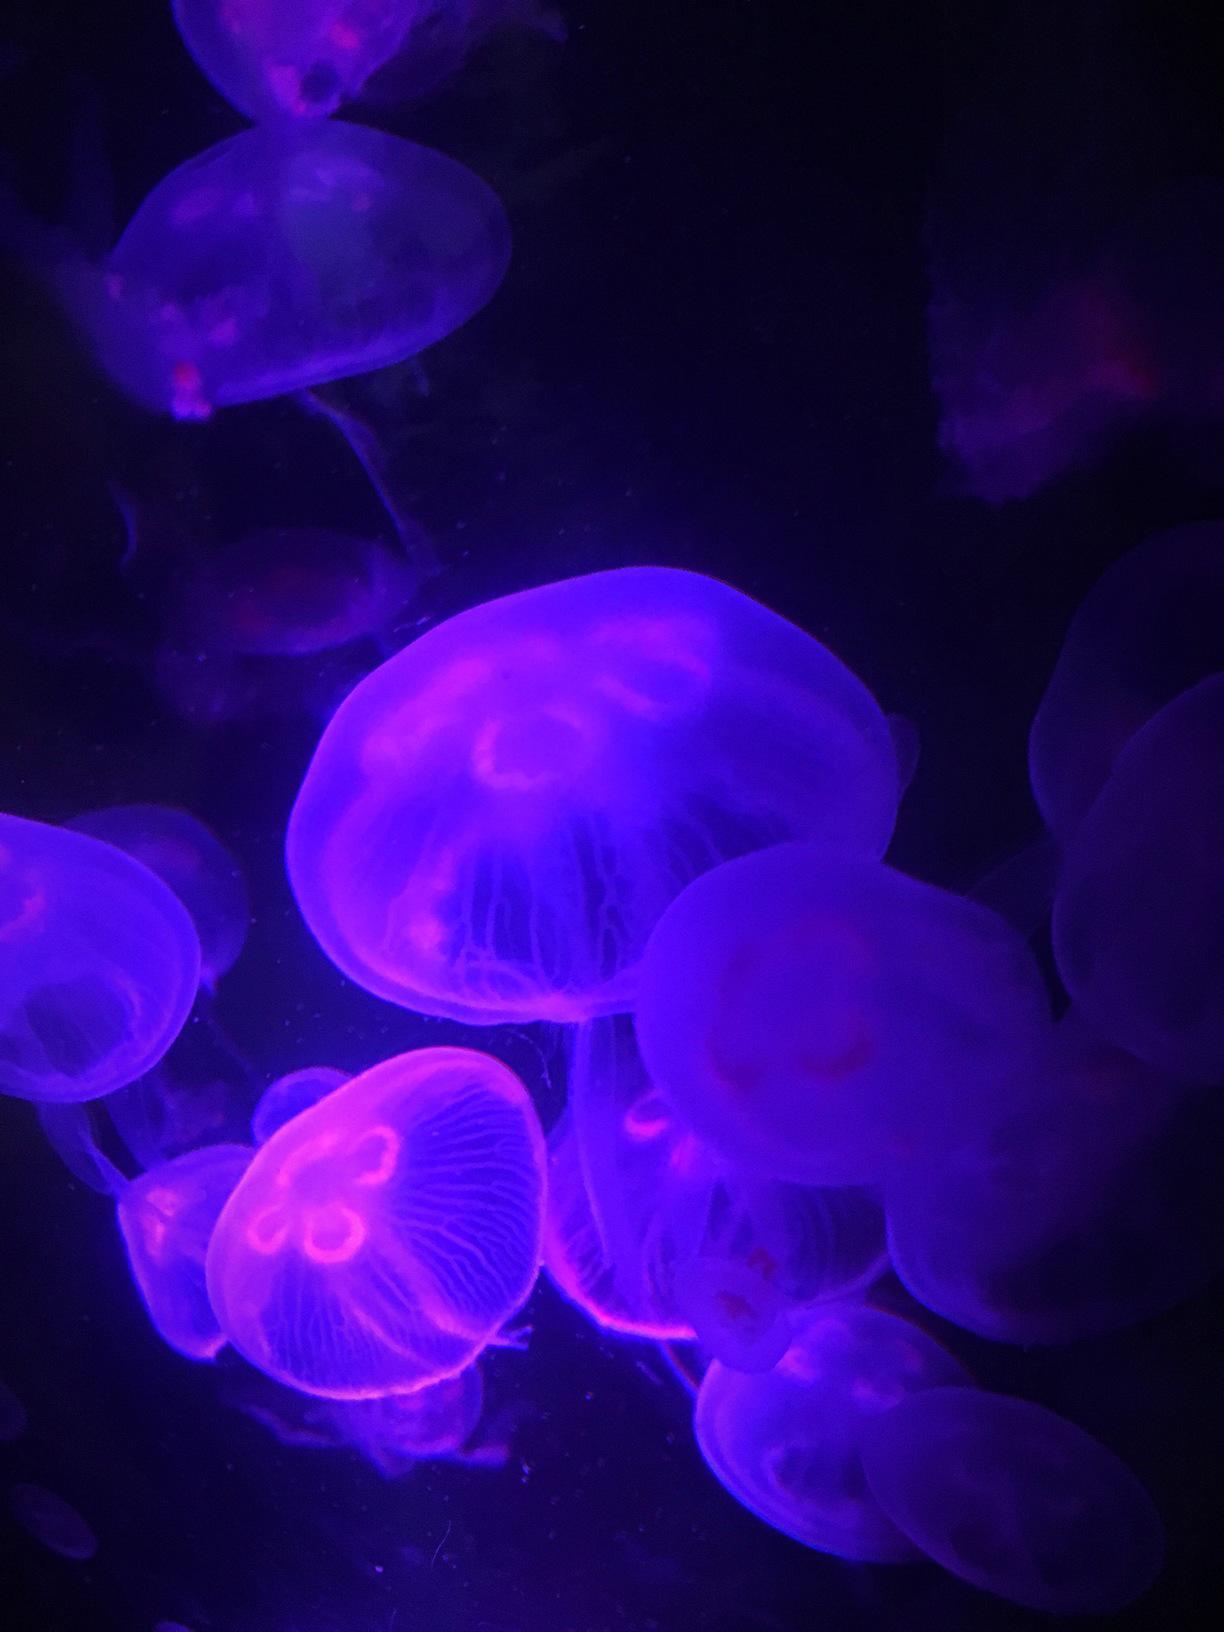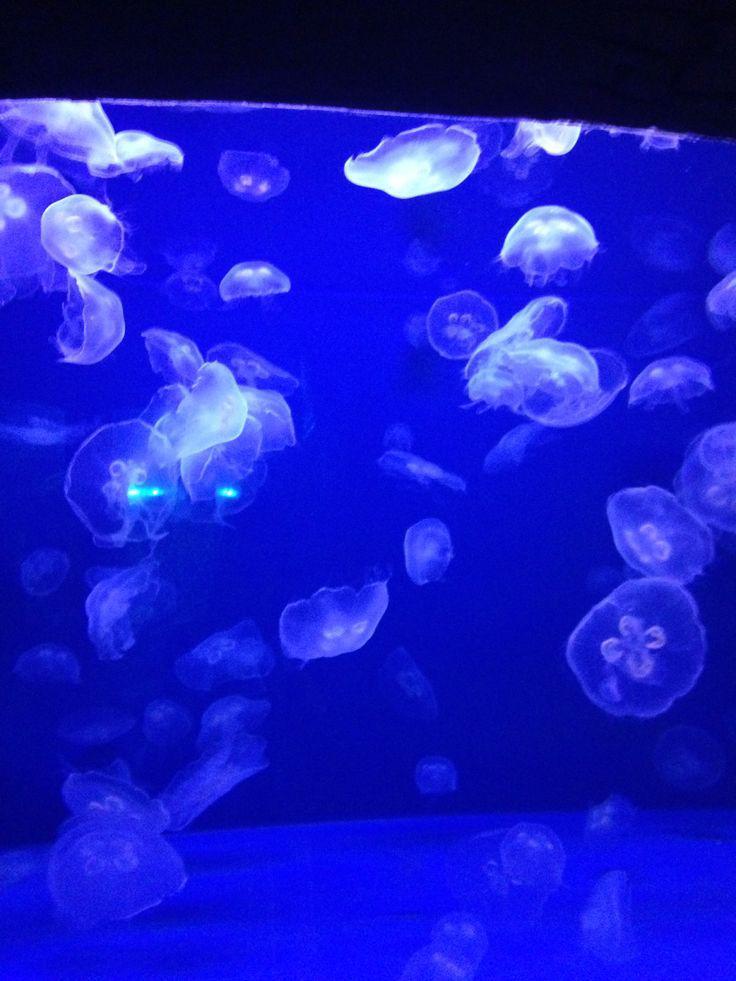The first image is the image on the left, the second image is the image on the right. Considering the images on both sides, is "Both images contain Moon Jelly jellyfish." valid? Answer yes or no. Yes. 